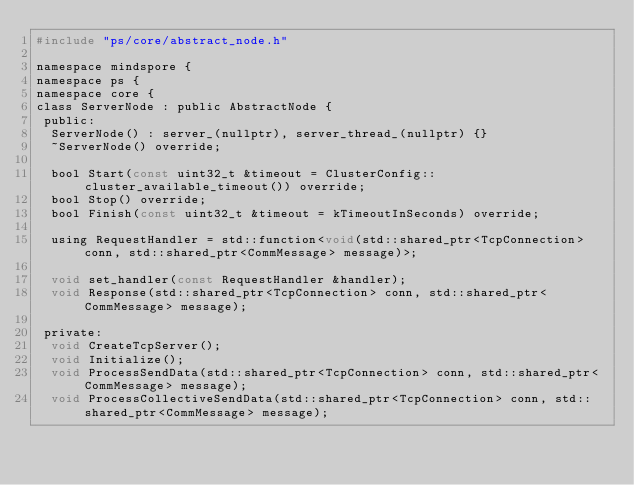Convert code to text. <code><loc_0><loc_0><loc_500><loc_500><_C_>#include "ps/core/abstract_node.h"

namespace mindspore {
namespace ps {
namespace core {
class ServerNode : public AbstractNode {
 public:
  ServerNode() : server_(nullptr), server_thread_(nullptr) {}
  ~ServerNode() override;

  bool Start(const uint32_t &timeout = ClusterConfig::cluster_available_timeout()) override;
  bool Stop() override;
  bool Finish(const uint32_t &timeout = kTimeoutInSeconds) override;

  using RequestHandler = std::function<void(std::shared_ptr<TcpConnection> conn, std::shared_ptr<CommMessage> message)>;

  void set_handler(const RequestHandler &handler);
  void Response(std::shared_ptr<TcpConnection> conn, std::shared_ptr<CommMessage> message);

 private:
  void CreateTcpServer();
  void Initialize();
  void ProcessSendData(std::shared_ptr<TcpConnection> conn, std::shared_ptr<CommMessage> message);
  void ProcessCollectiveSendData(std::shared_ptr<TcpConnection> conn, std::shared_ptr<CommMessage> message);
</code> 